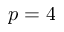<formula> <loc_0><loc_0><loc_500><loc_500>p = 4</formula> 